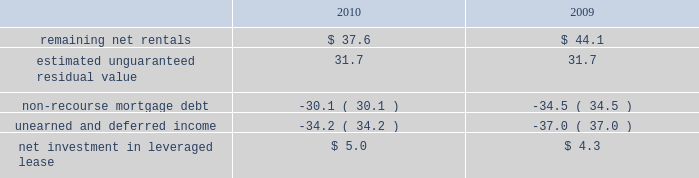Kimco realty corporation and subsidiaries notes to consolidated financial statements , continued investment in retail store leases 2014 the company has interests in various retail store leases relating to the anchor store premises in neighborhood and community shopping centers .
These premises have been sublet to retailers who lease the stores pursuant to net lease agreements .
Income from the investment in these retail store leases during the years ended december 31 , 2010 , 2009 and 2008 , was approximately $ 1.6 million , $ 0.8 million and $ 2.7 million , respectively .
These amounts represent sublease revenues during the years ended december 31 , 2010 , 2009 and 2008 , of approximately $ 5.9 million , $ 5.2 million and $ 7.1 million , respectively , less related expenses of $ 4.3 million , $ 4.4 million and $ 4.4 million , respectively .
The company 2019s future minimum revenues under the terms of all non-cancelable tenant subleases and future minimum obligations through the remaining terms of its retail store leases , assuming no new or renegotiated leases are executed for such premises , for future years are as follows ( in millions ) : 2011 , $ 5.2 and $ 3.4 ; 2012 , $ 4.1 and $ 2.6 ; 2013 , $ 3.8 and $ 2.3 ; 2014 , $ 2.9 and $ 1.7 ; 2015 , $ 2.1 and $ 1.3 , and thereafter , $ 2.8 and $ 1.6 , respectively .
Leveraged lease 2014 during june 2002 , the company acquired a 90% ( 90 % ) equity participation interest in an existing leveraged lease of 30 properties .
The properties are leased under a long-term bond-type net lease whose primary term expires in 2016 , with the lessee having certain renewal option rights .
The company 2019s cash equity investment was approximately $ 4.0 million .
This equity investment is reported as a net investment in leveraged lease in accordance with the fasb 2019s lease guidance .
As of december 31 , 2010 , 18 of these properties were sold , whereby the proceeds from the sales were used to pay down the mortgage debt by approximately $ 31.2 million and the remaining 12 properties were encumbered by third-party non-recourse debt of approximately $ 33.4 million that is scheduled to fully amortize during the primary term of the lease from a portion of the periodic net rents receivable under the net lease .
As an equity participant in the leveraged lease , the company has no recourse obligation for principal or interest payments on the debt , which is collateralized by a first mortgage lien on the properties and collateral assignment of the lease .
Accordingly , this obligation has been offset against the related net rental receivable under the lease .
At december 31 , 2010 and 2009 , the company 2019s net investment in the leveraged lease consisted of the following ( in millions ) : .
10 .
Variable interest entities : consolidated operating properties 2014 included within the company 2019s consolidated operating properties at december 31 , 2010 are four consolidated entities that are vies and for which the company is the primary beneficiary .
All of these entities have been established to own and operate real estate property .
The company 2019s involvement with these entities is through its majority ownership of the properties .
These entities were deemed vies primarily based on the fact that the voting rights of the equity investors are not proportional to their obligation to absorb expected losses or receive the expected residual returns of the entity and substantially all of the entity 2019s activities are conducted on behalf of the investor which has disproportionately fewer voting rights .
The company determined that it was the primary beneficiary of these vies as a result of its controlling financial interest .
During 2010 , the company sold two consolidated vie 2019s which the company was the primary beneficiary. .
What is the total sublease revenue , in millions , from 2008-2010? 
Computations: ((5.9 + 5.2) + 7.1)
Answer: 18.2. 